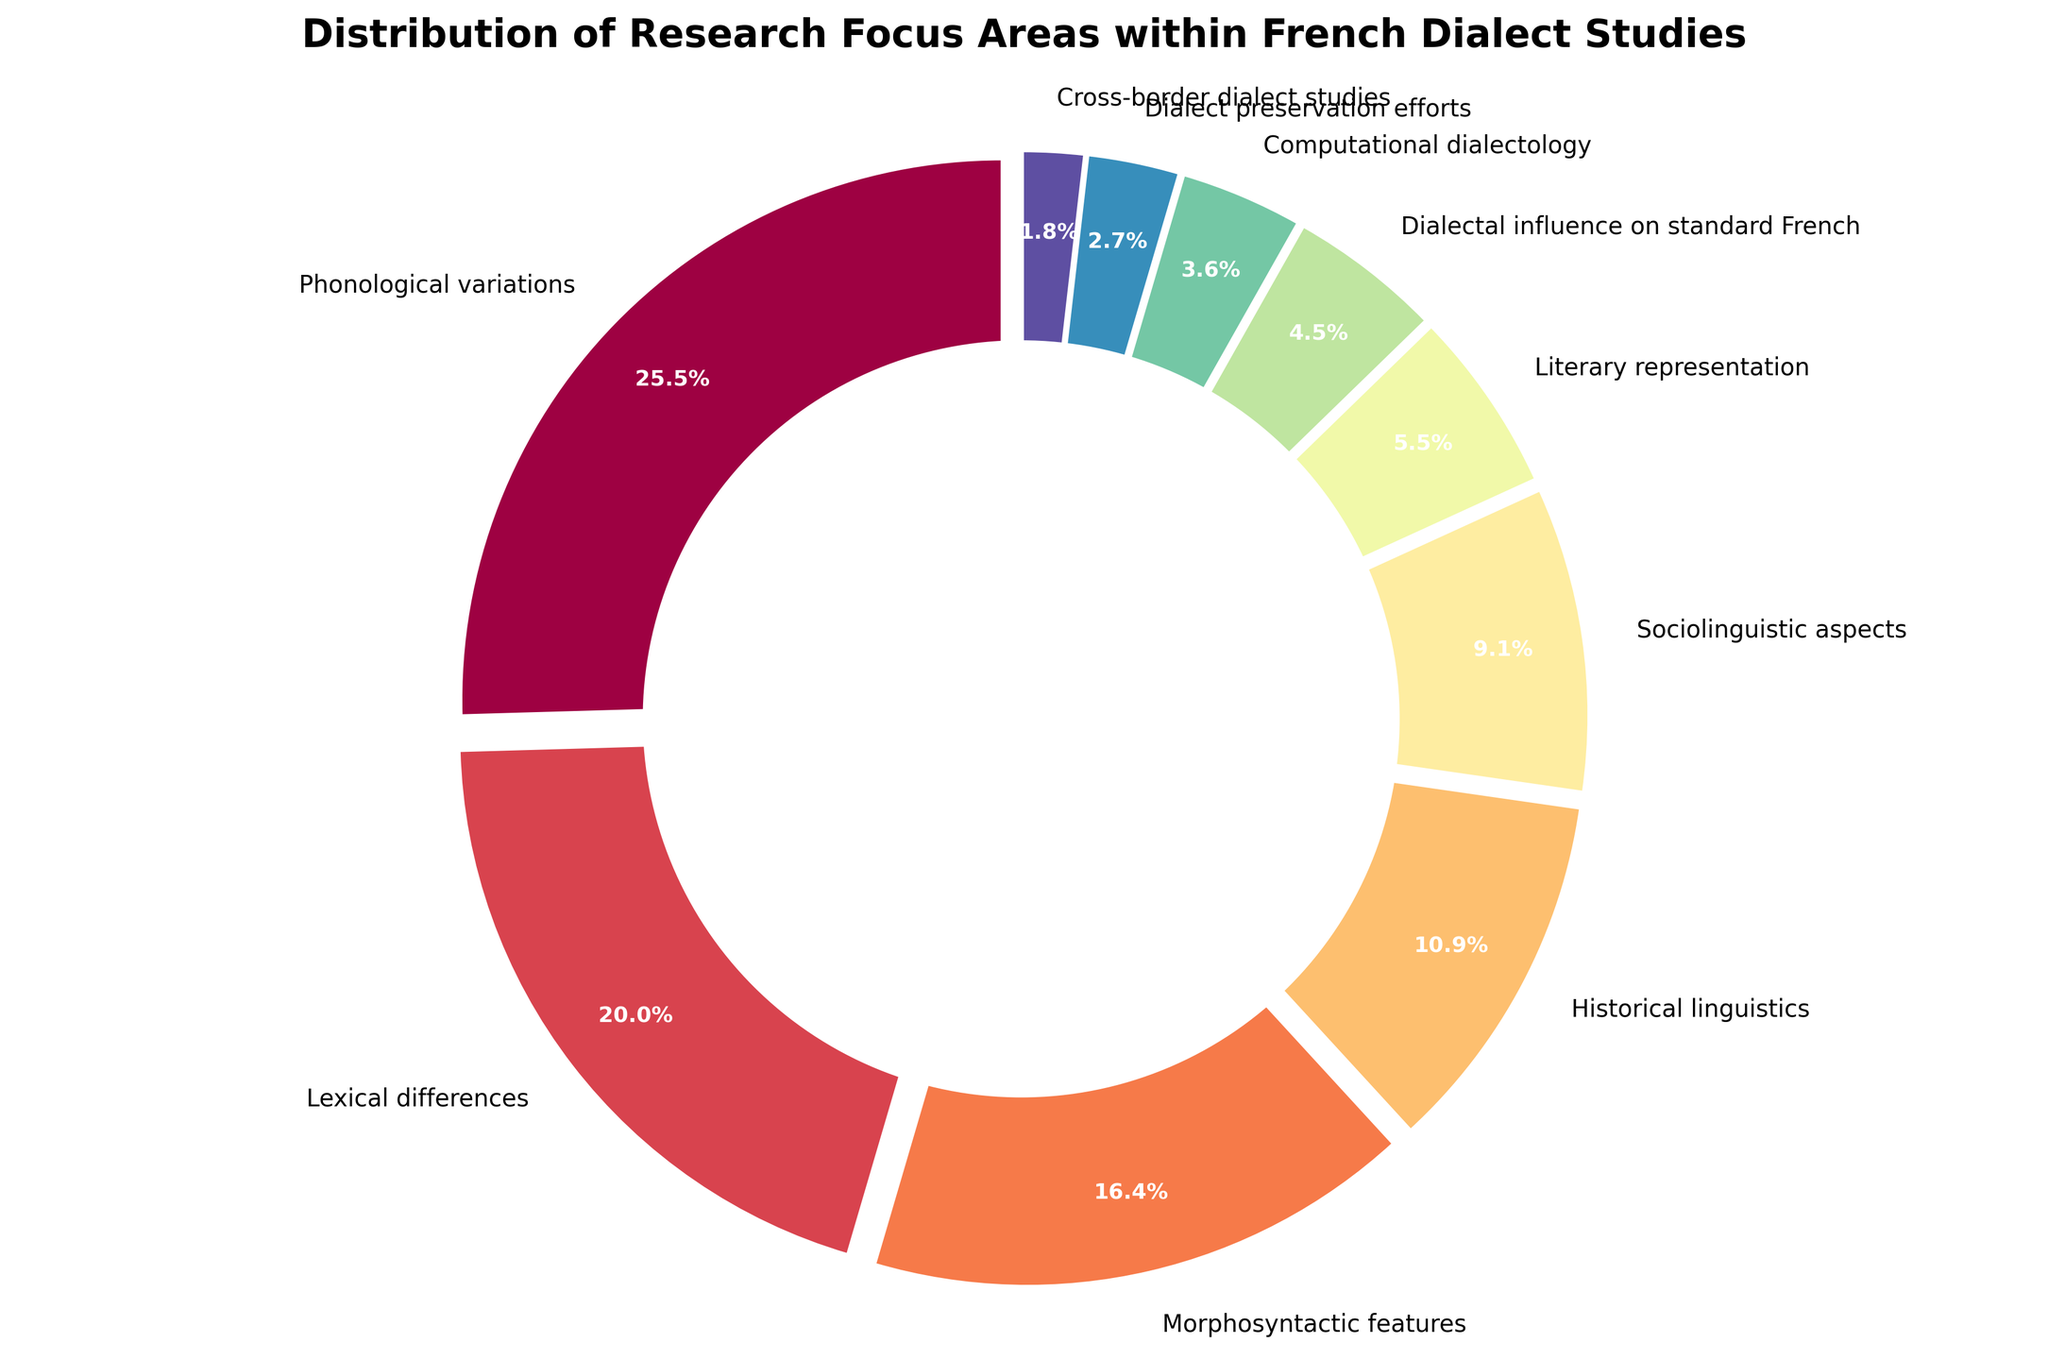Which category holds the second-largest percentage in the distribution? The percentage for each category is given directly on the chart. The second-largest percentage after Phonological variations (28%) is Lexical differences (22%).
Answer: Lexical differences What is the combined percentage for Morphosyntactic features and Historical linguistics? Morphosyntactic features have a percentage of 18%, and Historical linguistics have 12%. Adding these gives 18% + 12% = 30%.
Answer: 30% Are Lexical differences and Sociolinguistic aspects collectively greater than Phonological variations? Lexical differences amount to 22%, and Sociolinguistic aspects amount to 10%. Their combined percentage is 22% + 10% = 32%, which is greater than Phonological variations' 28%.
Answer: Yes Which category has the smallest percentage, and what is it? The chart indicates that Cross-border dialect studies have the smallest percentage at 2%.
Answer: Cross-border dialect studies, 2% How much more percentage does Phonological variations have compared to Literary representation? Phonological variations have 28%, whereas Literary representation has 6%. The difference is 28% - 6% = 22%.
Answer: 22% What is the median value among the given percentages? To find the median, first list the percentages in ascending order: 2, 3, 4, 5, 6, 10, 12, 18, 22, 28. The median is the middle value, which is (10 + 12) / 2 = 11%.
Answer: 11% Is the percentage for Dialect preservation efforts higher or lower than that for Computational dialectology? Dialect preservation efforts have a percentage of 3%, while Computational dialectology has 4%. 3% is lower than 4%.
Answer: Lower What is the total percentage of all categories related to sociolinguistic aspects? The relevant categories include Sociolinguistic aspects (10%), Lexical differences (22%), and Dialect preservation efforts (3%). Adding these gives 10% + 22% + 3% = 35%.
Answer: 35% Which category representing a linguistic feature has the highest percentage, and what is it? Among linguistic features, Phonological variations have the highest percentage at 28%.
Answer: Phonological variations, 28% How does the percentage of Literary representation compare to the average percentage of all categories? First, sum all percentages: 28 + 22 + 18 + 12 + 10 + 6 + 5 + 4 + 3 + 2 = 110%. Divide by 10 to get the average: 110% / 10 = 11%. Literary representation at 6% is lower than the average of 11%.
Answer: Lower 